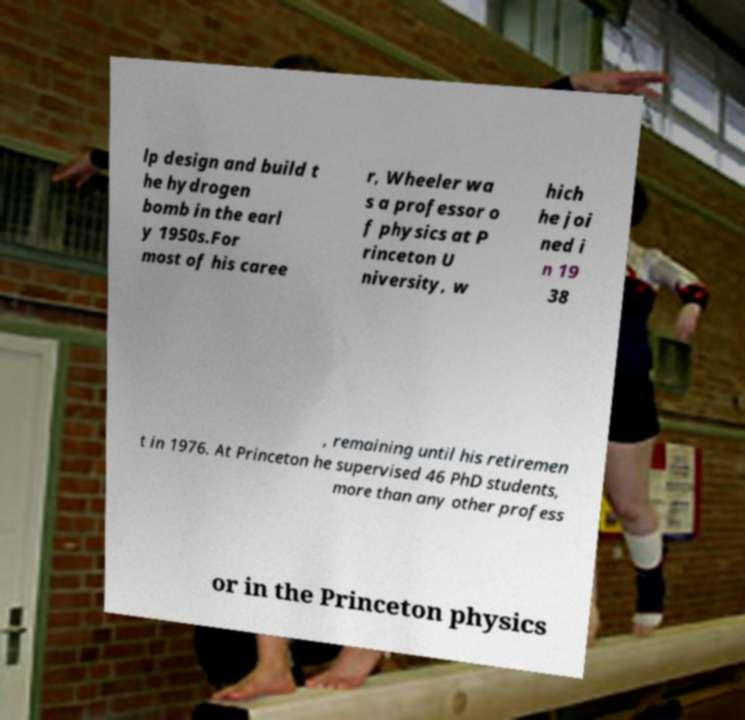There's text embedded in this image that I need extracted. Can you transcribe it verbatim? lp design and build t he hydrogen bomb in the earl y 1950s.For most of his caree r, Wheeler wa s a professor o f physics at P rinceton U niversity, w hich he joi ned i n 19 38 , remaining until his retiremen t in 1976. At Princeton he supervised 46 PhD students, more than any other profess or in the Princeton physics 